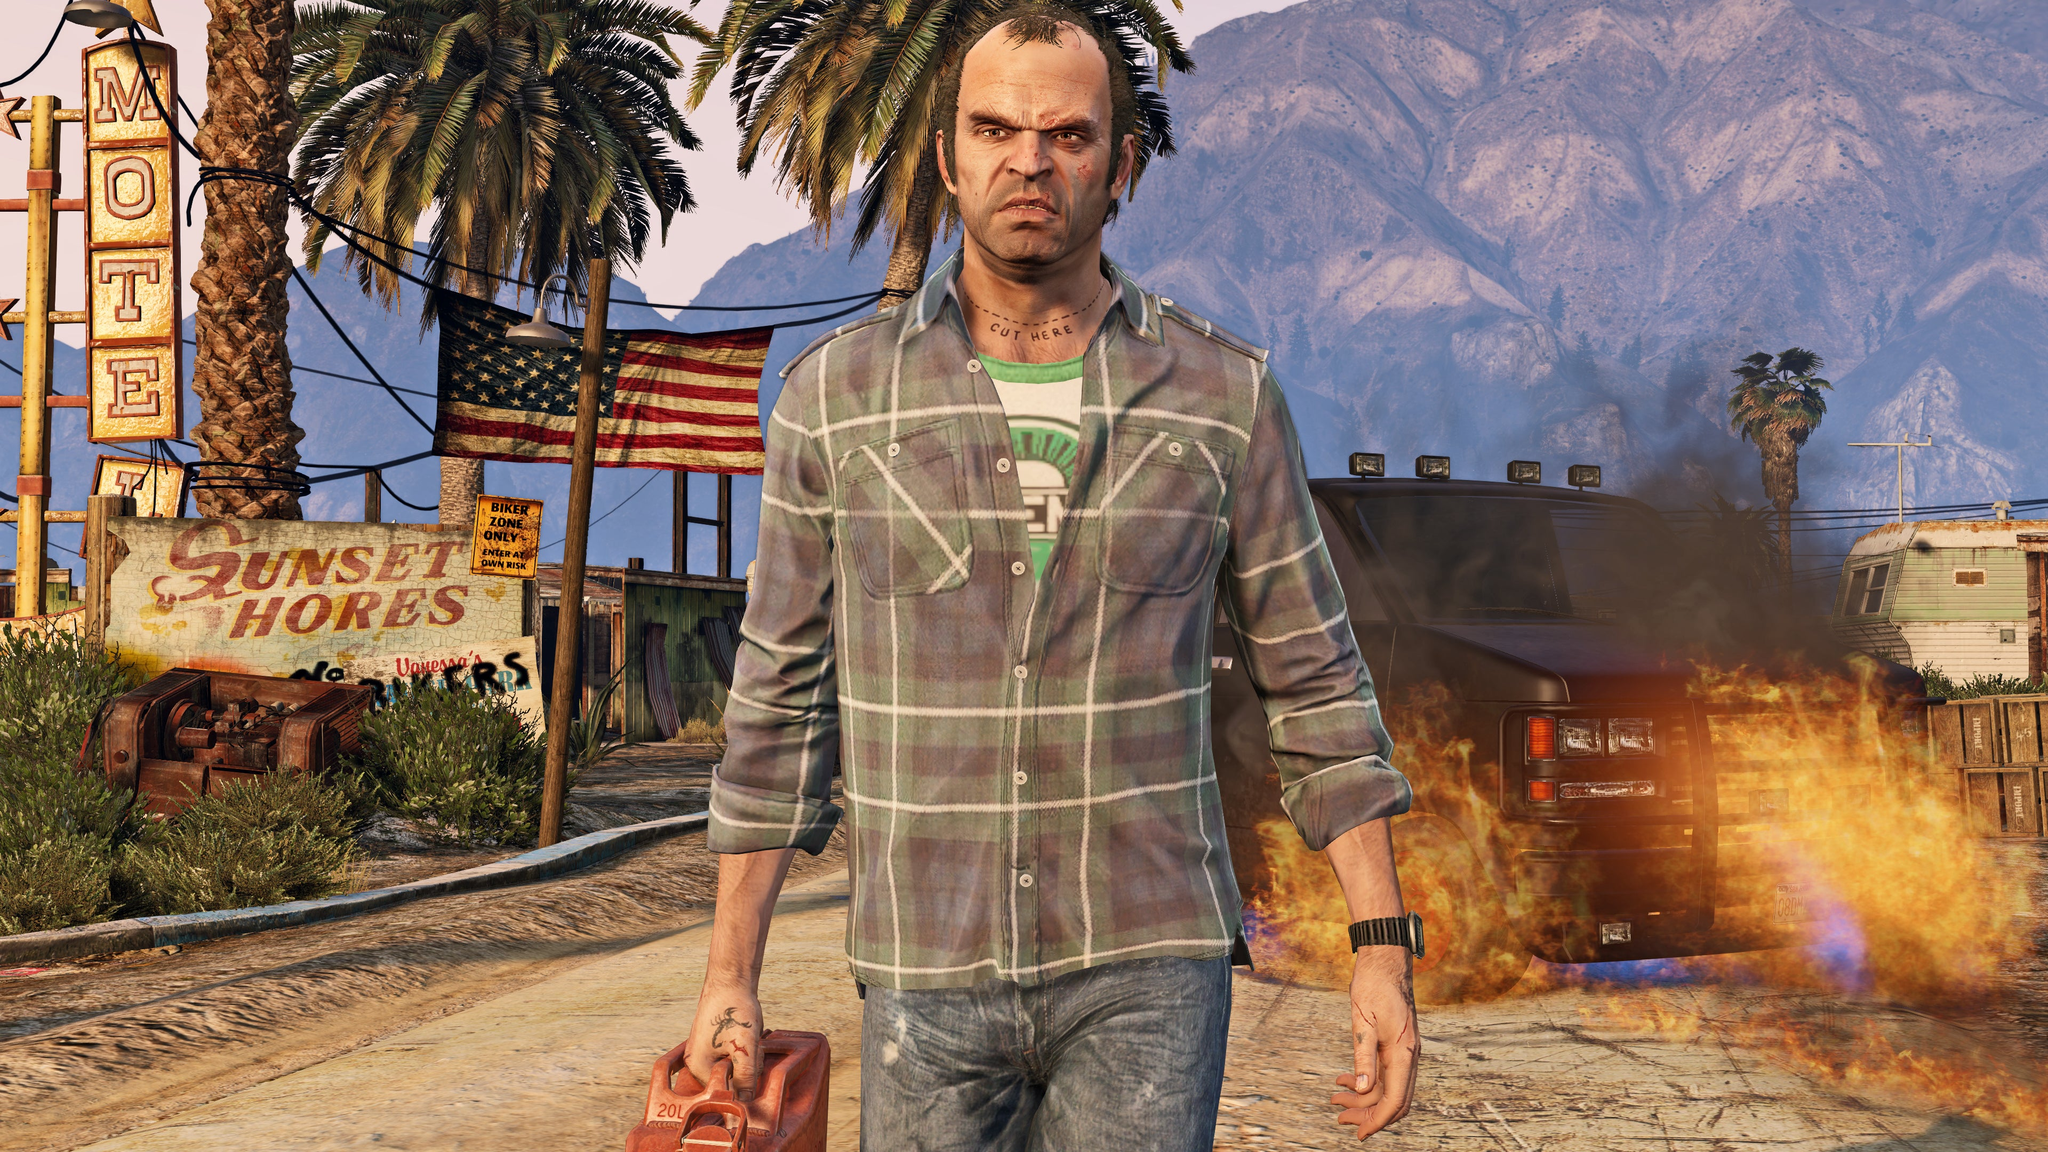What creative activities or stories can you come up with that involve the person in the image and the dilapidated setting? Imagine the character as an ex-detective turned vigilante, living in a town that has been overtaken by corrupt officials and criminal gangs. Every night, he prowls the streets, taking out threats and attempting to restore a semblance of peace. Meanwhile, he is haunted by a tragic past, with every new battle bringing him closer to unearthing the mysterious events that led to the town's downfall and claiming justice for his lost loved ones. He uses the motel as his base of operations, gradually recruiting other disillusioned residents to form a resistance group aimed at retaking their home. Imagine the area is actually part of a secret government experiment. How does this change the story? Discovering that the area is part of a secret government experiment drastically alters the narrative. The character in the image might be a former test subject who escaped or someone trying to uncover the truth behind the bizarre occurrences in the dilapidated town. The run-down setting is revealed to mask advanced technology and hidden surveillance equipment. The unattended fire could be a deliberate part of behavioral studies to observe reactions. This revelation turns the story into a sci-fi mystery, blending conspiracy and high-stakes espionage as the protagonist races against time to expose and shut down the experiment before it fully unravels societal norms. 